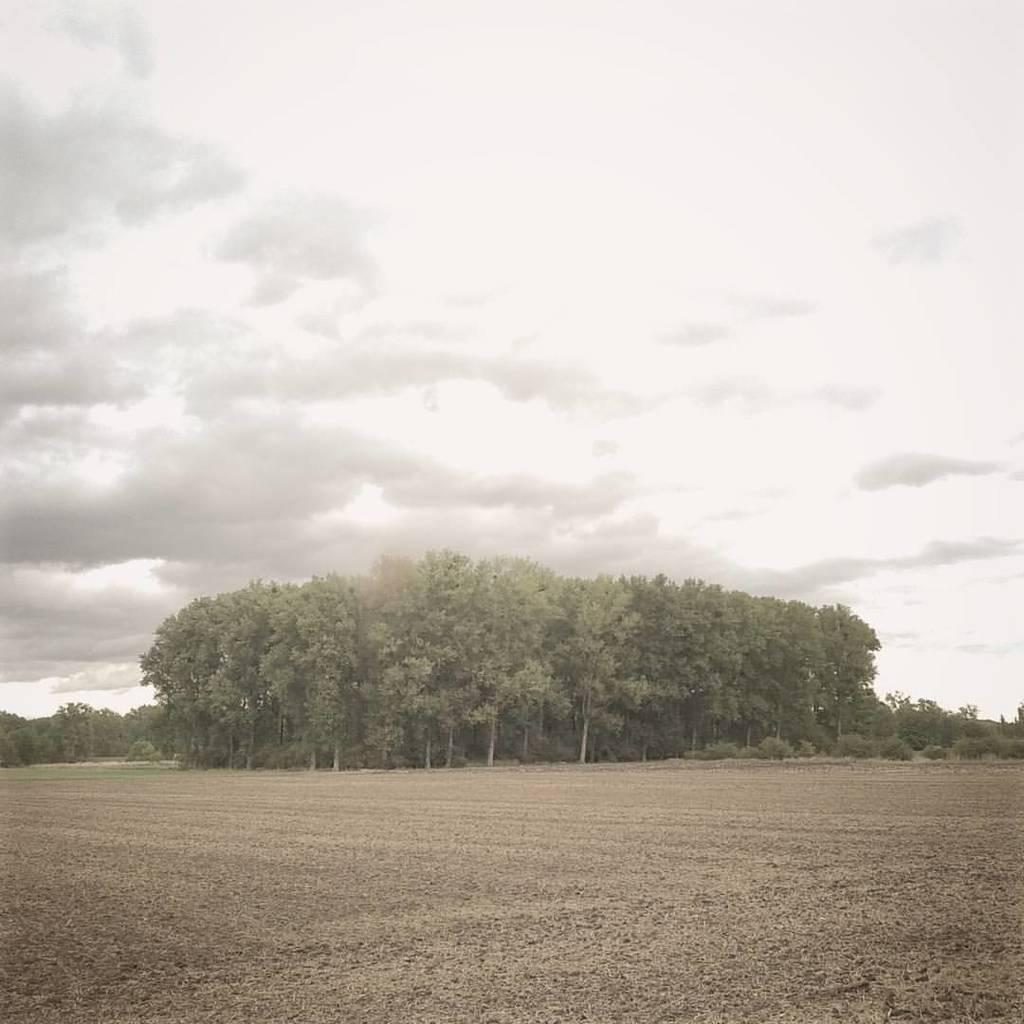How would you summarize this image in a sentence or two? In this image we can see a group of trees and in the background, we can see the cloudy sky. 